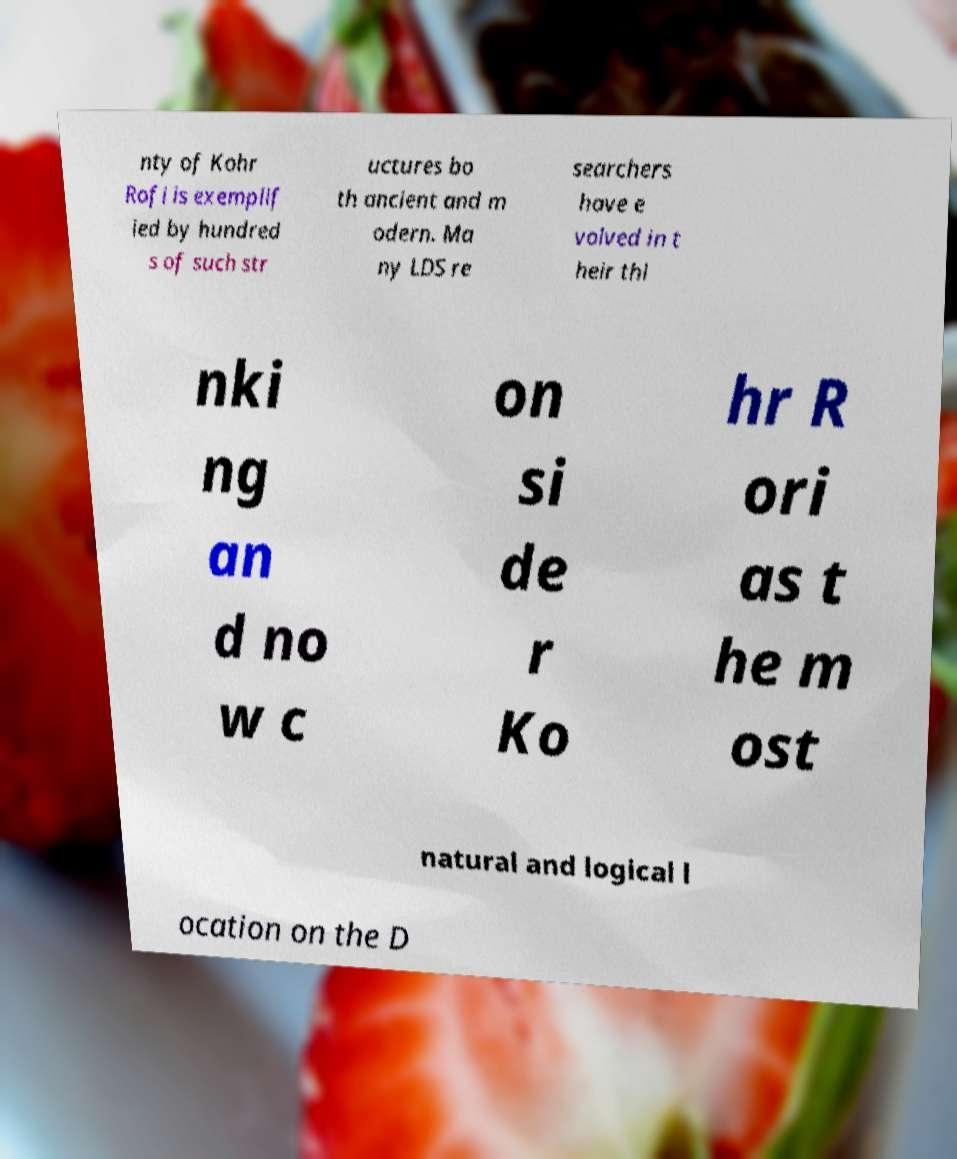Could you extract and type out the text from this image? nty of Kohr Rofi is exemplif ied by hundred s of such str uctures bo th ancient and m odern. Ma ny LDS re searchers have e volved in t heir thi nki ng an d no w c on si de r Ko hr R ori as t he m ost natural and logical l ocation on the D 